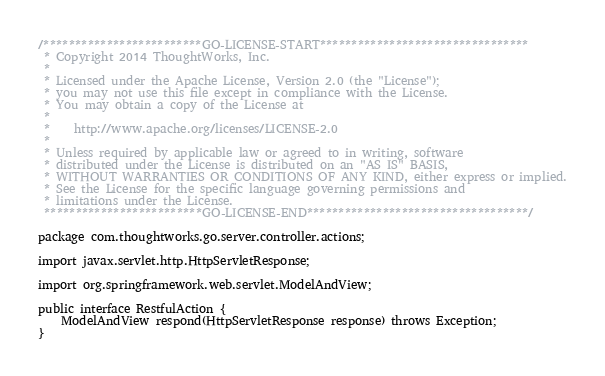<code> <loc_0><loc_0><loc_500><loc_500><_Java_>/*************************GO-LICENSE-START*********************************
 * Copyright 2014 ThoughtWorks, Inc.
 *
 * Licensed under the Apache License, Version 2.0 (the "License");
 * you may not use this file except in compliance with the License.
 * You may obtain a copy of the License at
 *
 *    http://www.apache.org/licenses/LICENSE-2.0
 *
 * Unless required by applicable law or agreed to in writing, software
 * distributed under the License is distributed on an "AS IS" BASIS,
 * WITHOUT WARRANTIES OR CONDITIONS OF ANY KIND, either express or implied.
 * See the License for the specific language governing permissions and
 * limitations under the License.
 *************************GO-LICENSE-END***********************************/

package com.thoughtworks.go.server.controller.actions;

import javax.servlet.http.HttpServletResponse;

import org.springframework.web.servlet.ModelAndView;

public interface RestfulAction {
    ModelAndView respond(HttpServletResponse response) throws Exception;
}
</code> 